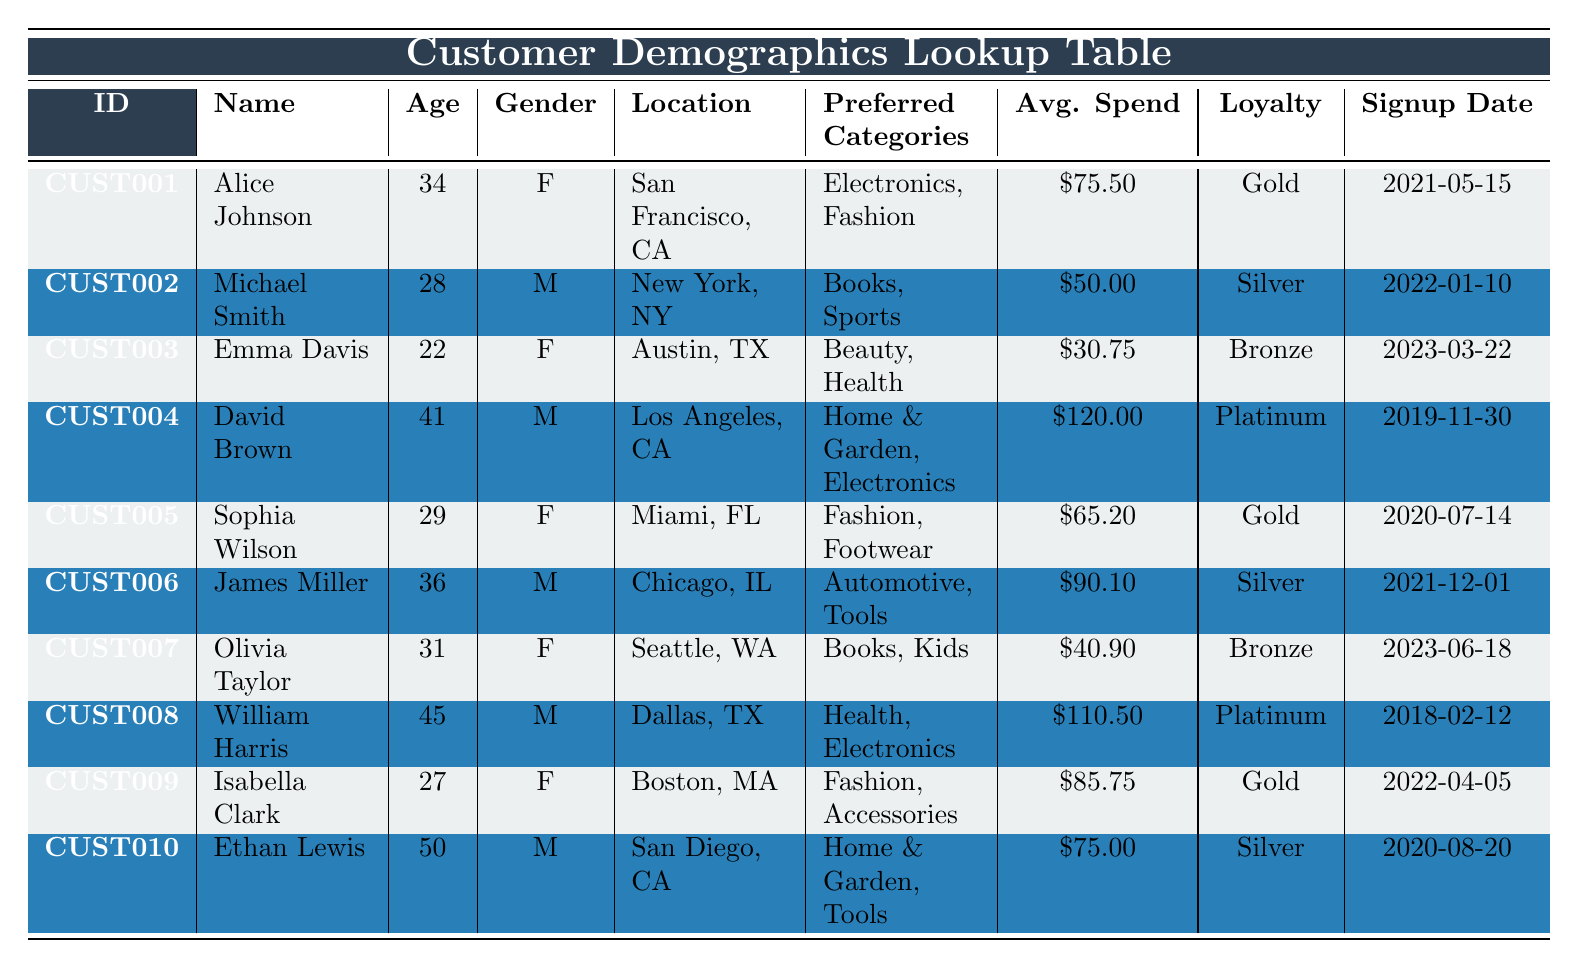What is the average spend per order of female customers? To find the average spend per order of female customers, we first identify the female customers: Alice Johnson ($75.50), Emma Davis ($30.75), Sophia Wilson ($65.20), and Olivia Taylor ($40.90). There are 4 female customers, and their total spend is $75.50 + $30.75 + $65.20 + $40.90 = $212.35. Now, dividing the total spend by the number of female customers gives us an average of $212.35 / 4 = $53.09.
Answer: 53.09 How many customers have a loyalty status of Gold? By scanning through the loyalty status column, the customers with a Gold status are Alice Johnson, Sophia Wilson, and Isabella Clark, which totals to 3 customers.
Answer: 3 Is there any customer from Los Angeles, CA? Checking the location column reveals that David Brown is listed as being from Los Angeles, CA. Therefore, the statement is true.
Answer: Yes Which customer has the highest average spend per order? By reviewing the average spend per order, David Brown has the highest at $120.00, compared to other customers.
Answer: David Brown What is the total number of customers who are aged above 30? Looking through the age column, the customers who are above 30 are Alice Johnson (34), David Brown (41), James Miller (36), William Harris (45), and Ethan Lewis (50). There are 5 customers above age 30.
Answer: 5 What is the median age of all customers? To find the median, we list the ages in ascending order: 22, 27, 28, 29, 31, 34, 36, 41, 45, 50. With 10 customers, the median is the average of the 5th and 6th values: (29 + 31) / 2 = 30. The median age is therefore 30.
Answer: 30 Are there more male customers than female customers? Counting the gender column shows that there are 5 males (Michael Smith, David Brown, James Miller, William Harris, Ethan Lewis) and 5 females (Alice Johnson, Emma Davis, Sophia Wilson, Olivia Taylor, Isabella Clark). Thus, the number of male and female customers is equal.
Answer: No What are the preferred categories of the customer with the lowest average spend per order? Emma Davis has the lowest average spend per order of $30.75, and her preferred categories are Beauty and Health.
Answer: Beauty and Health How many customers signed up in the year 2021? Scanning the signup date column reveals that Alice Johnson (2021-05-15), James Miller (2021-12-01) are the only customers that signed up in 2021, making the total 2 customers.
Answer: 2 